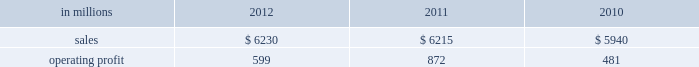Printing papers demand for printing papers products is closely corre- lated with changes in commercial printing and advertising activity , direct mail volumes and , for uncoated cut-size products , with changes in white- collar employment levels that affect the usage of copy and laser printer paper .
Pulp is further affected by changes in currency rates that can enhance or disadvantage producers in different geographic regions .
Principal cost drivers include manufacturing efficiency , raw material and energy costs and freight costs .
Pr int ing papers net sales for 2012 were about flat with 2011 and increased 5% ( 5 % ) from 2010 .
Operat- ing profits in 2012 were 31% ( 31 % ) lower than in 2011 , but 25% ( 25 % ) higher than in 2010 .
Excluding facility closure costs and impairment costs , operating profits in 2012 were 30% ( 30 % ) lower than in 2011 and 25% ( 25 % ) lower than in 2010 .
Benefits from higher sales volumes ( $ 58 mil- lion ) were more than offset by lower sales price real- izations and an unfavorable product mix ( $ 233 million ) , higher operating costs ( $ 30 million ) , higher maintenance outage costs ( $ 17 million ) , higher input costs ( $ 32 million ) and other items ( $ 6 million ) .
In addition , operating profits in 2011 included a $ 24 million gain related to the announced repurposing of our franklin , virginia mill to produce fluff pulp and an $ 11 million impairment charge related to our inverurie , scotland mill that was closed in 2009 .
Printing papers .
North american pr int ing papers net sales were $ 2.7 billion in 2012 , $ 2.8 billion in 2011 and $ 2.8 billion in 2010 .
Operating profits in 2012 were $ 331 million compared with $ 423 million ( $ 399 million excluding a $ 24 million gain associated with the repurposing of our franklin , virginia mill ) in 2011 and $ 18 million ( $ 333 million excluding facility clo- sure costs ) in 2010 .
Sales volumes in 2012 were flat with 2011 .
Average sales margins were lower primarily due to lower export sales prices and higher export sales volume .
Input costs were higher for wood and chemicals , but were partially offset by lower purchased pulp costs .
Freight costs increased due to higher oil prices .
Manufacturing operating costs were favorable reflecting strong mill performance .
Planned main- tenance downtime costs were slightly higher in 2012 .
No market-related downtime was taken in either 2012 or 2011 .
Entering the first quarter of 2013 , sales volumes are expected to increase compared with the fourth quar- ter of 2012 reflecting seasonally stronger demand .
Average sales price realizations are expected to be relatively flat as sales price realizations for domestic and export uncoated freesheet roll and cutsize paper should be stable .
Input costs should increase for energy , chemicals and wood .
Planned maintenance downtime costs are expected to be about $ 19 million lower with an outage scheduled at our georgetown mill versus outages at our courtland and eastover mills in the fourth quarter of 2012 .
Braz i l ian papers net sales for 2012 were $ 1.1 bil- lion compared with $ 1.2 billion in 2011 and $ 1.1 bil- lion in 2010 .
Operating profits for 2012 were $ 163 million compared with $ 169 million in 2011 and $ 159 million in 2010 .
Sales volumes in 2012 were higher than in 2011 as international paper improved its segment position in the brazilian market despite weaker year-over-year conditions in most markets .
Average sales price realizations improved for domestic uncoated freesheet paper , but the benefit was more than offset by declining prices for exported paper .
Margins were favorably affected by an increased proportion of sales to the higher- margin domestic market .
Raw material costs increased for wood and chemicals , but costs for purchased pulp decreased .
Operating costs and planned maintenance downtime costs were lower than in 2011 .
Looking ahead to 2013 , sales volumes in the first quarter are expected to be lower than in the fourth quarter of 2012 due to seasonally weaker customer demand for uncoated freesheet paper .
Average sales price realizations are expected to increase in the brazilian domestic market due to the realization of an announced sales price increase for uncoated free- sheet paper , but the benefit should be partially offset by pricing pressures in export markets .
Average sales margins are expected to be negatively impacted by a less favorable geographic mix .
Input costs are expected to be about flat due to lower energy costs being offset by higher costs for wood , purchased pulp , chemicals and utilities .
Planned maintenance outage costs should be $ 4 million lower with no outages scheduled in the first quarter .
Operating costs should be favorably impacted by the savings generated by the start-up of a new biomass boiler at the mogi guacu mill .
European papers net sales in 2012 were $ 1.4 bil- lion compared with $ 1.4 billion in 2011 and $ 1.3 bil- lion in 2010 .
Operating profits in 2012 were $ 179 million compared with $ 196 million ( $ 207 million excluding asset impairment charges related to our inverurie , scotland mill which was closed in 2009 ) in 2011 and $ 197 million ( $ 199 million excluding an asset impairment charge ) in 2010 .
Sales volumes in 2012 compared with 2011 were higher for uncoated freesheet paper in both europe and russia , while sales volumes for pulp were lower in both regions .
Average sales price realizations for uncoated .
What was the change in operating profits in 2012 in millions? 
Computations: (163 - 169)
Answer: -6.0. Printing papers demand for printing papers products is closely corre- lated with changes in commercial printing and advertising activity , direct mail volumes and , for uncoated cut-size products , with changes in white- collar employment levels that affect the usage of copy and laser printer paper .
Pulp is further affected by changes in currency rates that can enhance or disadvantage producers in different geographic regions .
Principal cost drivers include manufacturing efficiency , raw material and energy costs and freight costs .
Pr int ing papers net sales for 2012 were about flat with 2011 and increased 5% ( 5 % ) from 2010 .
Operat- ing profits in 2012 were 31% ( 31 % ) lower than in 2011 , but 25% ( 25 % ) higher than in 2010 .
Excluding facility closure costs and impairment costs , operating profits in 2012 were 30% ( 30 % ) lower than in 2011 and 25% ( 25 % ) lower than in 2010 .
Benefits from higher sales volumes ( $ 58 mil- lion ) were more than offset by lower sales price real- izations and an unfavorable product mix ( $ 233 million ) , higher operating costs ( $ 30 million ) , higher maintenance outage costs ( $ 17 million ) , higher input costs ( $ 32 million ) and other items ( $ 6 million ) .
In addition , operating profits in 2011 included a $ 24 million gain related to the announced repurposing of our franklin , virginia mill to produce fluff pulp and an $ 11 million impairment charge related to our inverurie , scotland mill that was closed in 2009 .
Printing papers .
North american pr int ing papers net sales were $ 2.7 billion in 2012 , $ 2.8 billion in 2011 and $ 2.8 billion in 2010 .
Operating profits in 2012 were $ 331 million compared with $ 423 million ( $ 399 million excluding a $ 24 million gain associated with the repurposing of our franklin , virginia mill ) in 2011 and $ 18 million ( $ 333 million excluding facility clo- sure costs ) in 2010 .
Sales volumes in 2012 were flat with 2011 .
Average sales margins were lower primarily due to lower export sales prices and higher export sales volume .
Input costs were higher for wood and chemicals , but were partially offset by lower purchased pulp costs .
Freight costs increased due to higher oil prices .
Manufacturing operating costs were favorable reflecting strong mill performance .
Planned main- tenance downtime costs were slightly higher in 2012 .
No market-related downtime was taken in either 2012 or 2011 .
Entering the first quarter of 2013 , sales volumes are expected to increase compared with the fourth quar- ter of 2012 reflecting seasonally stronger demand .
Average sales price realizations are expected to be relatively flat as sales price realizations for domestic and export uncoated freesheet roll and cutsize paper should be stable .
Input costs should increase for energy , chemicals and wood .
Planned maintenance downtime costs are expected to be about $ 19 million lower with an outage scheduled at our georgetown mill versus outages at our courtland and eastover mills in the fourth quarter of 2012 .
Braz i l ian papers net sales for 2012 were $ 1.1 bil- lion compared with $ 1.2 billion in 2011 and $ 1.1 bil- lion in 2010 .
Operating profits for 2012 were $ 163 million compared with $ 169 million in 2011 and $ 159 million in 2010 .
Sales volumes in 2012 were higher than in 2011 as international paper improved its segment position in the brazilian market despite weaker year-over-year conditions in most markets .
Average sales price realizations improved for domestic uncoated freesheet paper , but the benefit was more than offset by declining prices for exported paper .
Margins were favorably affected by an increased proportion of sales to the higher- margin domestic market .
Raw material costs increased for wood and chemicals , but costs for purchased pulp decreased .
Operating costs and planned maintenance downtime costs were lower than in 2011 .
Looking ahead to 2013 , sales volumes in the first quarter are expected to be lower than in the fourth quarter of 2012 due to seasonally weaker customer demand for uncoated freesheet paper .
Average sales price realizations are expected to increase in the brazilian domestic market due to the realization of an announced sales price increase for uncoated free- sheet paper , but the benefit should be partially offset by pricing pressures in export markets .
Average sales margins are expected to be negatively impacted by a less favorable geographic mix .
Input costs are expected to be about flat due to lower energy costs being offset by higher costs for wood , purchased pulp , chemicals and utilities .
Planned maintenance outage costs should be $ 4 million lower with no outages scheduled in the first quarter .
Operating costs should be favorably impacted by the savings generated by the start-up of a new biomass boiler at the mogi guacu mill .
European papers net sales in 2012 were $ 1.4 bil- lion compared with $ 1.4 billion in 2011 and $ 1.3 bil- lion in 2010 .
Operating profits in 2012 were $ 179 million compared with $ 196 million ( $ 207 million excluding asset impairment charges related to our inverurie , scotland mill which was closed in 2009 ) in 2011 and $ 197 million ( $ 199 million excluding an asset impairment charge ) in 2010 .
Sales volumes in 2012 compared with 2011 were higher for uncoated freesheet paper in both europe and russia , while sales volumes for pulp were lower in both regions .
Average sales price realizations for uncoated .
What was the operating margin from printing papers in 2012? 
Computations: (599 / 6230)
Answer: 0.09615. 